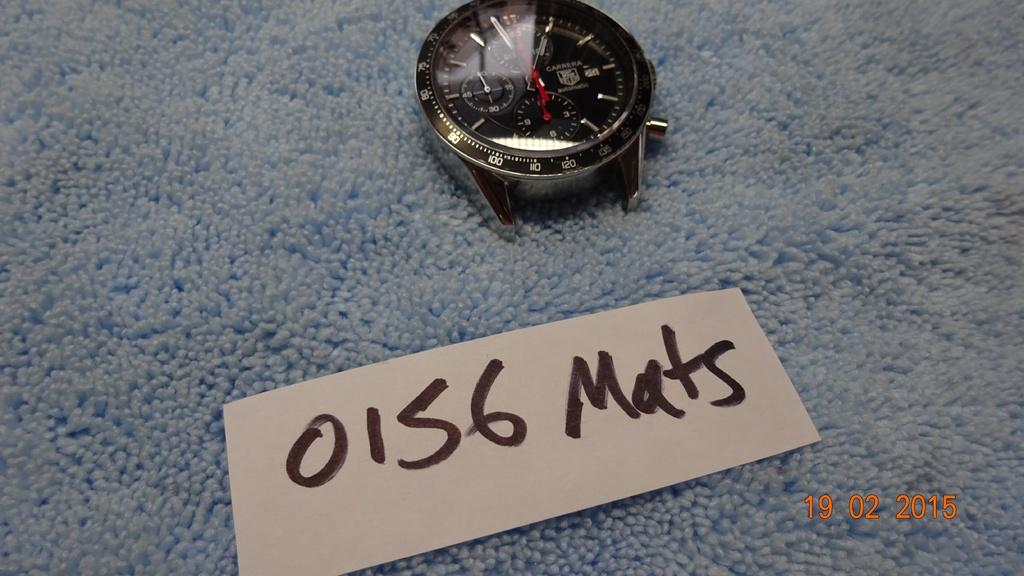<image>
Create a compact narrative representing the image presented. a wrist watch in front of a sign reading 0156 Mats 